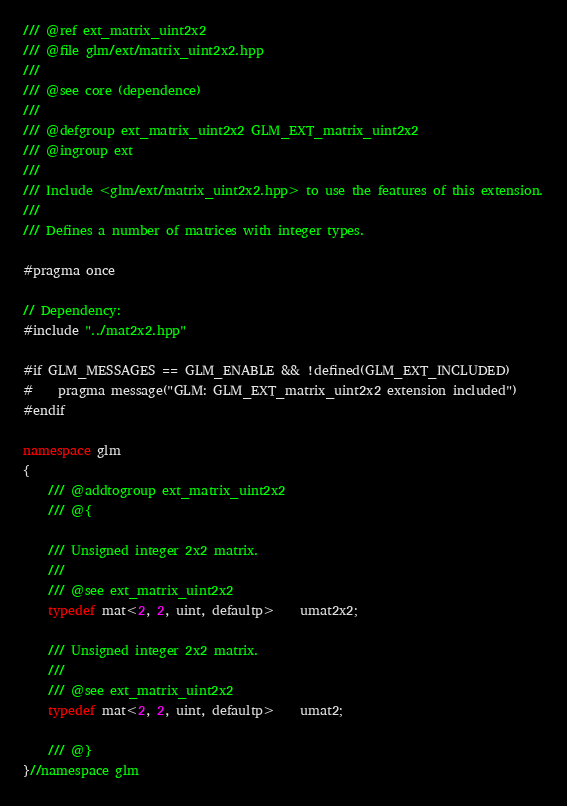<code> <loc_0><loc_0><loc_500><loc_500><_C++_>/// @ref ext_matrix_uint2x2
/// @file glm/ext/matrix_uint2x2.hpp
///
/// @see core (dependence)
///
/// @defgroup ext_matrix_uint2x2 GLM_EXT_matrix_uint2x2
/// @ingroup ext
///
/// Include <glm/ext/matrix_uint2x2.hpp> to use the features of this extension.
///
/// Defines a number of matrices with integer types.

#pragma once

// Dependency:
#include "../mat2x2.hpp"

#if GLM_MESSAGES == GLM_ENABLE && !defined(GLM_EXT_INCLUDED)
#	pragma message("GLM: GLM_EXT_matrix_uint2x2 extension included")
#endif

namespace glm
{
	/// @addtogroup ext_matrix_uint2x2
	/// @{

	/// Unsigned integer 2x2 matrix.
	///
	/// @see ext_matrix_uint2x2
	typedef mat<2, 2, uint, defaultp>	umat2x2;

	/// Unsigned integer 2x2 matrix.
	///
	/// @see ext_matrix_uint2x2
	typedef mat<2, 2, uint, defaultp>	umat2;

	/// @}
}//namespace glm
</code> 